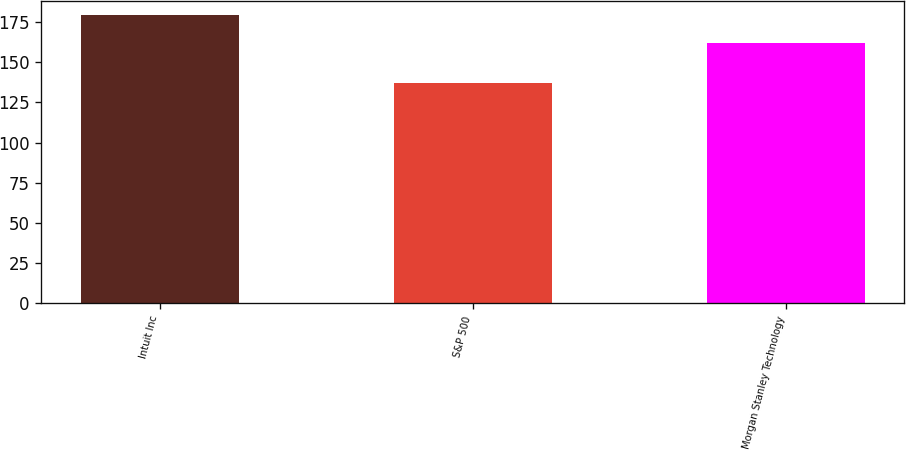Convert chart. <chart><loc_0><loc_0><loc_500><loc_500><bar_chart><fcel>Intuit Inc<fcel>S&P 500<fcel>Morgan Stanley Technology<nl><fcel>179.46<fcel>137.35<fcel>161.79<nl></chart> 